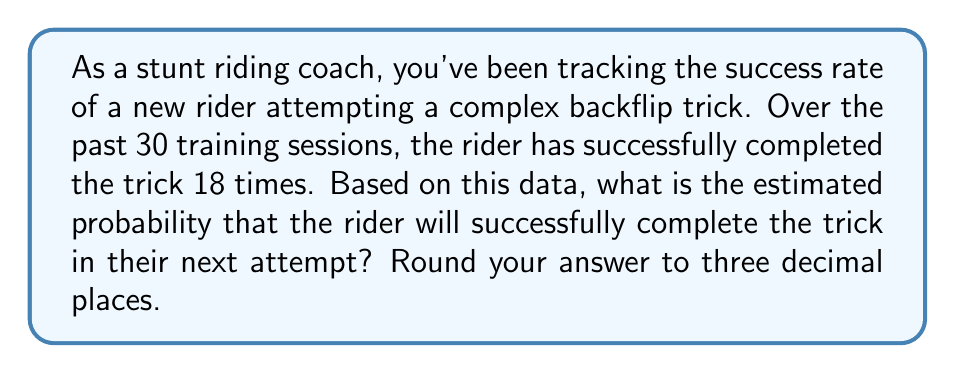Solve this math problem. To estimate the probability of a successful trick completion based on historical performance data, we can use the concept of relative frequency as an approximation of probability.

The relative frequency of an event is calculated by dividing the number of successful outcomes by the total number of trials:

$$ P(\text{success}) \approx \frac{\text{number of successes}}{\text{total number of trials}} $$

In this case:
- Number of successful completions: 18
- Total number of training sessions: 30

Let's plug these values into our formula:

$$ P(\text{success}) \approx \frac{18}{30} $$

To calculate this:

$$ \frac{18}{30} = 0.6 $$

Rounding to three decimal places:

$$ 0.6 = 0.600 $$

Therefore, based on the historical performance data, we estimate that the probability of the rider successfully completing the trick in their next attempt is 0.600 or 60.0%.
Answer: 0.600 